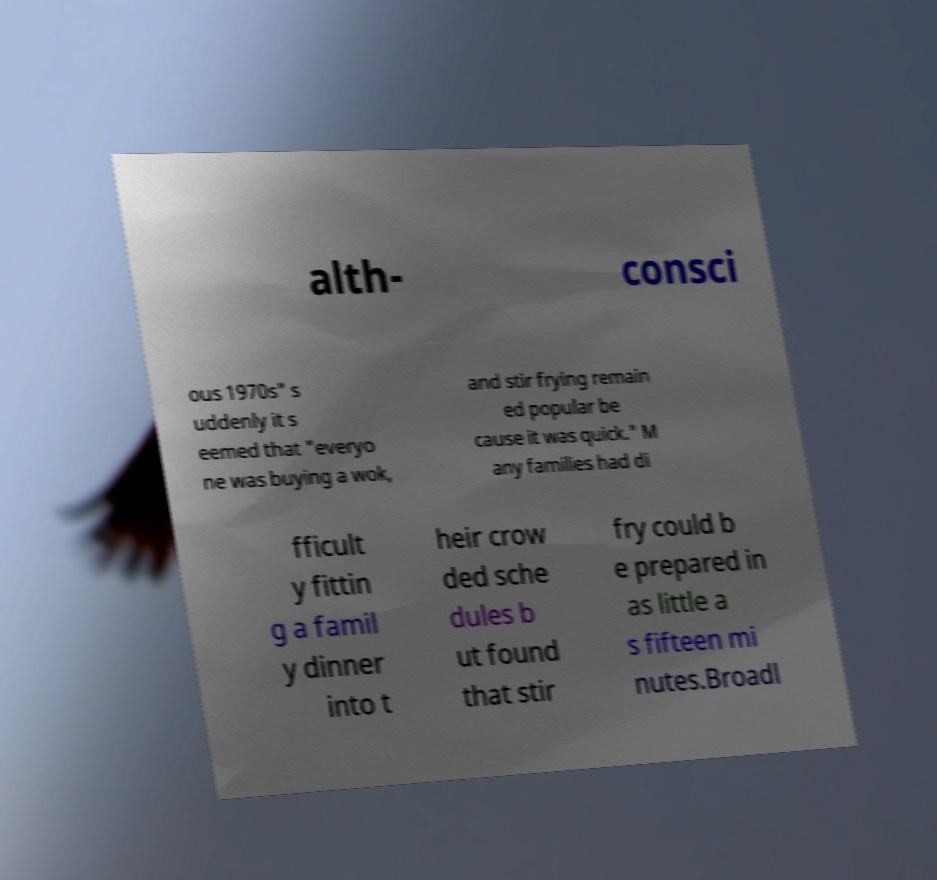There's text embedded in this image that I need extracted. Can you transcribe it verbatim? alth- consci ous 1970s" s uddenly it s eemed that "everyo ne was buying a wok, and stir frying remain ed popular be cause it was quick." M any families had di fficult y fittin g a famil y dinner into t heir crow ded sche dules b ut found that stir fry could b e prepared in as little a s fifteen mi nutes.Broadl 